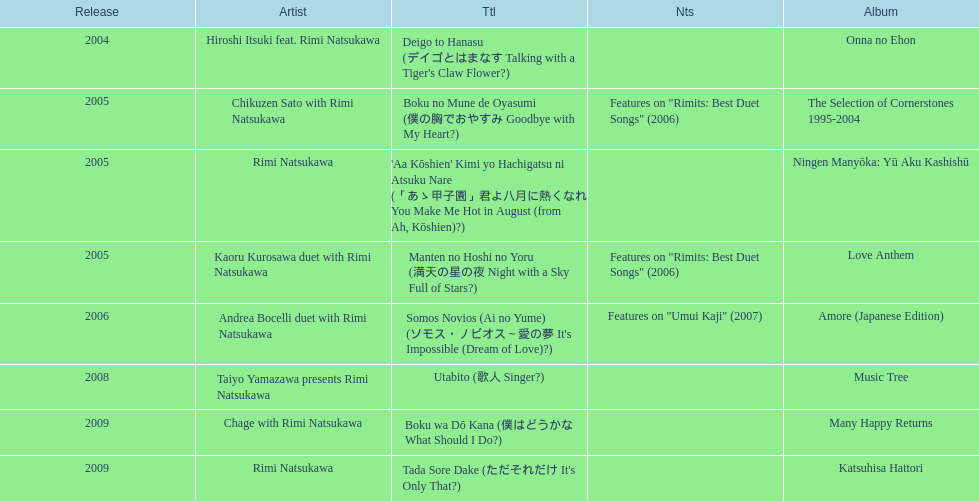What year was the first title released? 2004. 